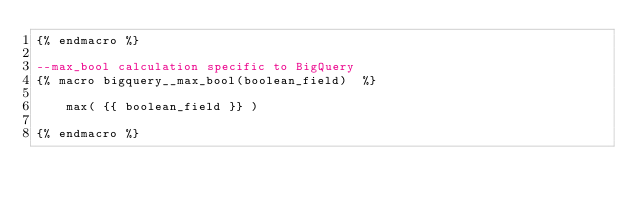<code> <loc_0><loc_0><loc_500><loc_500><_SQL_>{% endmacro %}

--max_bool calculation specific to BigQuery
{% macro bigquery__max_bool(boolean_field)  %}

    max( {{ boolean_field }} )

{% endmacro %}</code> 